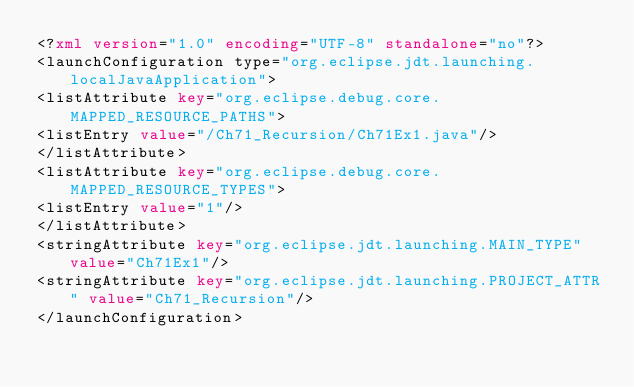Convert code to text. <code><loc_0><loc_0><loc_500><loc_500><_XML_><?xml version="1.0" encoding="UTF-8" standalone="no"?>
<launchConfiguration type="org.eclipse.jdt.launching.localJavaApplication">
<listAttribute key="org.eclipse.debug.core.MAPPED_RESOURCE_PATHS">
<listEntry value="/Ch71_Recursion/Ch71Ex1.java"/>
</listAttribute>
<listAttribute key="org.eclipse.debug.core.MAPPED_RESOURCE_TYPES">
<listEntry value="1"/>
</listAttribute>
<stringAttribute key="org.eclipse.jdt.launching.MAIN_TYPE" value="Ch71Ex1"/>
<stringAttribute key="org.eclipse.jdt.launching.PROJECT_ATTR" value="Ch71_Recursion"/>
</launchConfiguration>
</code> 